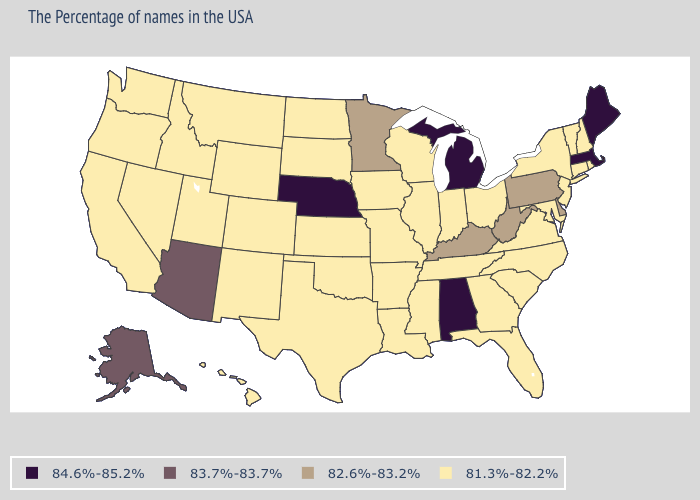Name the states that have a value in the range 84.6%-85.2%?
Be succinct. Maine, Massachusetts, Michigan, Alabama, Nebraska. Does Wisconsin have the highest value in the USA?
Concise answer only. No. What is the value of California?
Concise answer only. 81.3%-82.2%. Among the states that border Nevada , which have the highest value?
Answer briefly. Arizona. What is the value of West Virginia?
Short answer required. 82.6%-83.2%. Among the states that border Indiana , does Michigan have the lowest value?
Be succinct. No. Which states hav the highest value in the MidWest?
Be succinct. Michigan, Nebraska. What is the lowest value in the MidWest?
Give a very brief answer. 81.3%-82.2%. How many symbols are there in the legend?
Write a very short answer. 4. Does the map have missing data?
Write a very short answer. No. What is the value of Washington?
Quick response, please. 81.3%-82.2%. Name the states that have a value in the range 81.3%-82.2%?
Short answer required. Rhode Island, New Hampshire, Vermont, Connecticut, New York, New Jersey, Maryland, Virginia, North Carolina, South Carolina, Ohio, Florida, Georgia, Indiana, Tennessee, Wisconsin, Illinois, Mississippi, Louisiana, Missouri, Arkansas, Iowa, Kansas, Oklahoma, Texas, South Dakota, North Dakota, Wyoming, Colorado, New Mexico, Utah, Montana, Idaho, Nevada, California, Washington, Oregon, Hawaii. Does Alaska have the lowest value in the West?
Quick response, please. No. What is the value of South Dakota?
Write a very short answer. 81.3%-82.2%. What is the highest value in the USA?
Concise answer only. 84.6%-85.2%. 